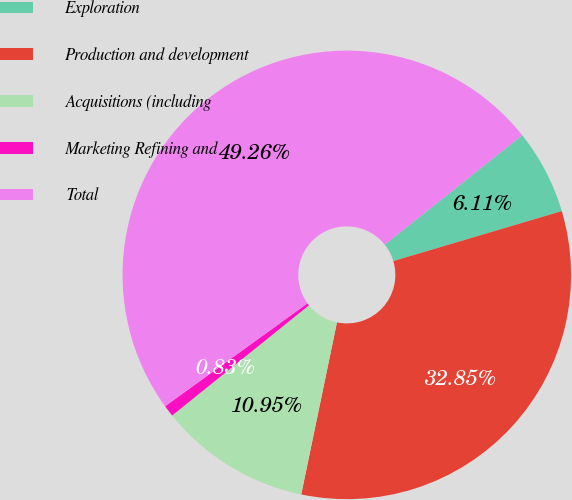Convert chart. <chart><loc_0><loc_0><loc_500><loc_500><pie_chart><fcel>Exploration<fcel>Production and development<fcel>Acquisitions (including<fcel>Marketing Refining and<fcel>Total<nl><fcel>6.11%<fcel>32.85%<fcel>10.95%<fcel>0.83%<fcel>49.26%<nl></chart> 